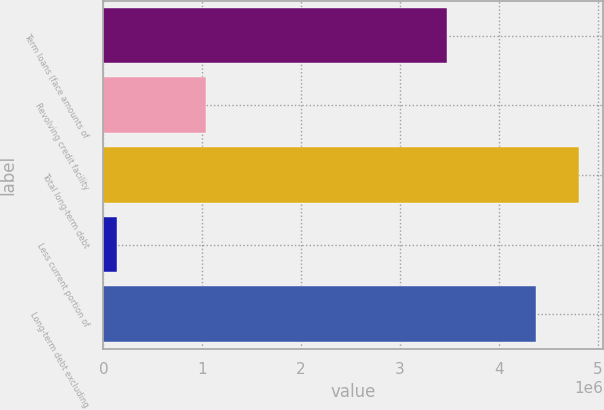Convert chart. <chart><loc_0><loc_0><loc_500><loc_500><bar_chart><fcel>Term loans (face amounts of<fcel>Revolving credit facility<fcel>Total long-term debt<fcel>Less current portion of<fcel>Long-term debt excluding<nl><fcel>3.47823e+06<fcel>1.037e+06<fcel>4.81772e+06<fcel>135542<fcel>4.37974e+06<nl></chart> 